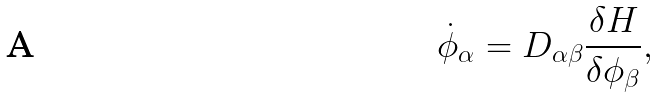Convert formula to latex. <formula><loc_0><loc_0><loc_500><loc_500>\dot { \phi } _ { \alpha } = D _ { \alpha \beta } \frac { \delta H } { \delta \phi _ { \beta } } ,</formula> 